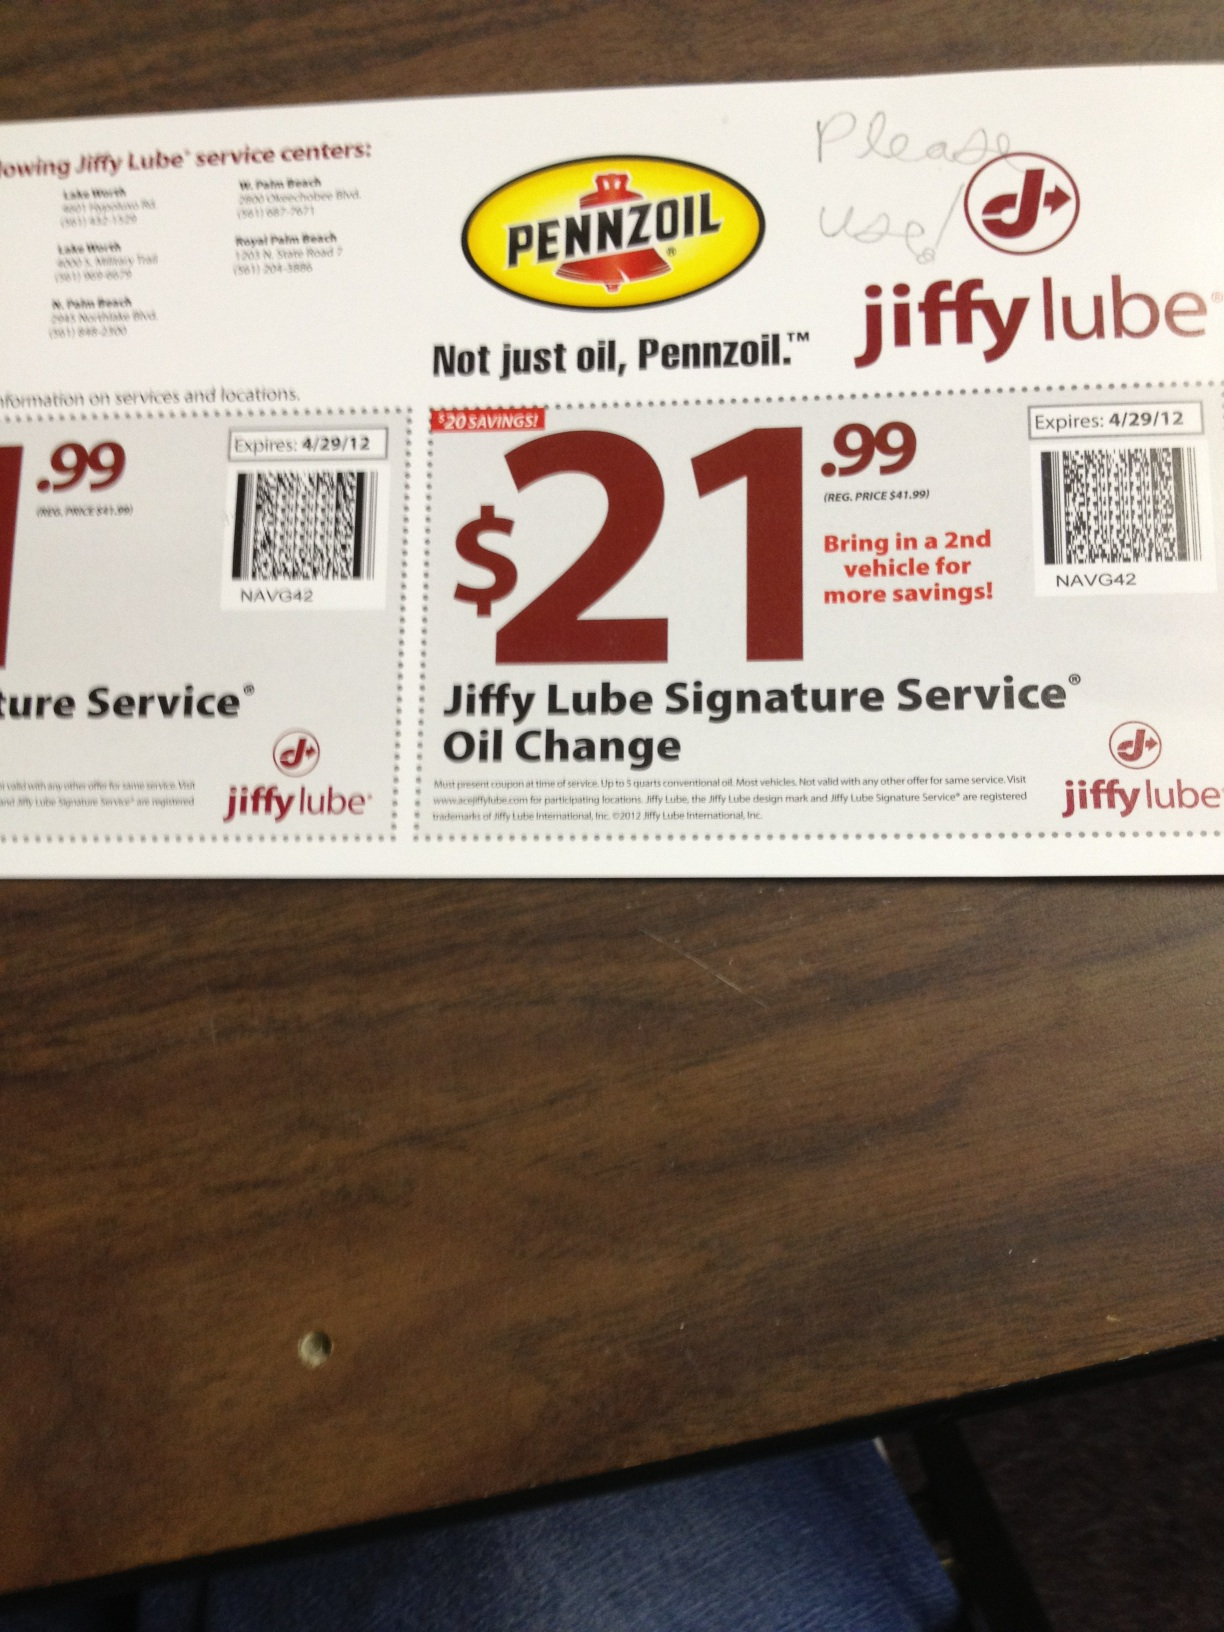Describe the validity period of this coupon. The coupon is valid until April 29, 2012, as stated on the coupon. 